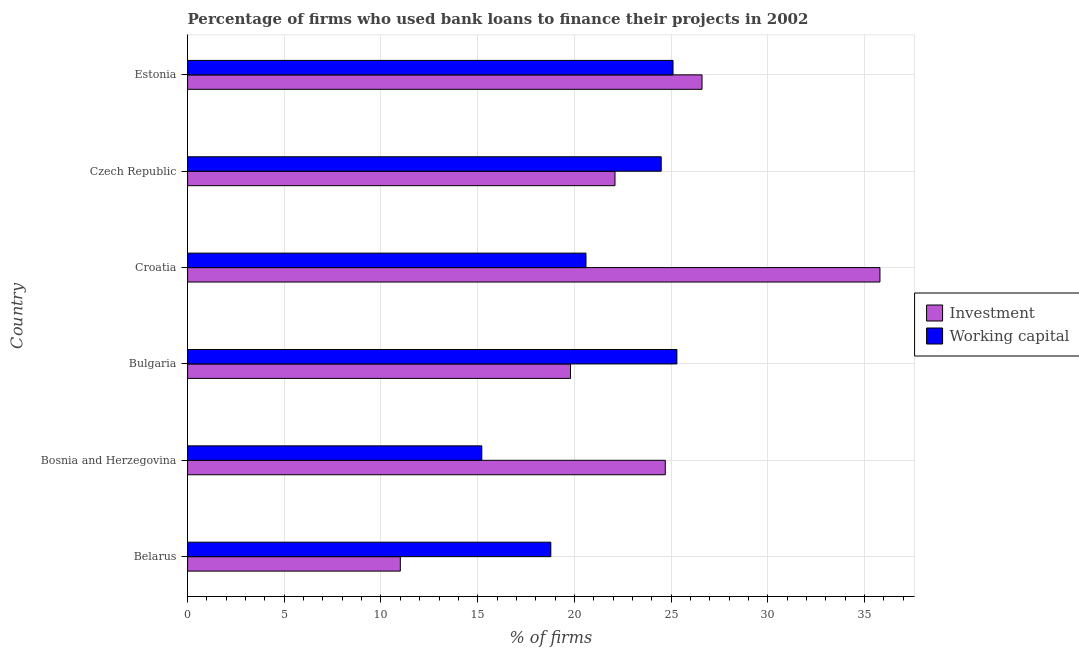Are the number of bars per tick equal to the number of legend labels?
Keep it short and to the point. Yes. Are the number of bars on each tick of the Y-axis equal?
Keep it short and to the point. Yes. What is the label of the 5th group of bars from the top?
Keep it short and to the point. Bosnia and Herzegovina. What is the percentage of firms using banks to finance working capital in Bosnia and Herzegovina?
Your answer should be very brief. 15.21. Across all countries, what is the maximum percentage of firms using banks to finance investment?
Offer a terse response. 35.8. Across all countries, what is the minimum percentage of firms using banks to finance investment?
Keep it short and to the point. 11. In which country was the percentage of firms using banks to finance working capital maximum?
Give a very brief answer. Bulgaria. In which country was the percentage of firms using banks to finance investment minimum?
Provide a short and direct response. Belarus. What is the total percentage of firms using banks to finance working capital in the graph?
Offer a terse response. 129.48. What is the difference between the percentage of firms using banks to finance working capital in Estonia and the percentage of firms using banks to finance investment in Croatia?
Provide a short and direct response. -10.7. What is the average percentage of firms using banks to finance working capital per country?
Provide a succinct answer. 21.58. What is the difference between the percentage of firms using banks to finance working capital and percentage of firms using banks to finance investment in Croatia?
Make the answer very short. -15.2. What is the ratio of the percentage of firms using banks to finance working capital in Bulgaria to that in Croatia?
Give a very brief answer. 1.23. Is the percentage of firms using banks to finance working capital in Croatia less than that in Estonia?
Your answer should be very brief. Yes. What is the difference between the highest and the lowest percentage of firms using banks to finance investment?
Ensure brevity in your answer.  24.8. In how many countries, is the percentage of firms using banks to finance working capital greater than the average percentage of firms using banks to finance working capital taken over all countries?
Ensure brevity in your answer.  3. Is the sum of the percentage of firms using banks to finance working capital in Bosnia and Herzegovina and Estonia greater than the maximum percentage of firms using banks to finance investment across all countries?
Provide a short and direct response. Yes. What does the 2nd bar from the top in Croatia represents?
Offer a terse response. Investment. What does the 1st bar from the bottom in Bulgaria represents?
Your answer should be compact. Investment. Are all the bars in the graph horizontal?
Your answer should be very brief. Yes. How many countries are there in the graph?
Offer a very short reply. 6. What is the difference between two consecutive major ticks on the X-axis?
Your response must be concise. 5. Are the values on the major ticks of X-axis written in scientific E-notation?
Offer a terse response. No. Where does the legend appear in the graph?
Offer a terse response. Center right. How many legend labels are there?
Offer a terse response. 2. How are the legend labels stacked?
Provide a short and direct response. Vertical. What is the title of the graph?
Keep it short and to the point. Percentage of firms who used bank loans to finance their projects in 2002. What is the label or title of the X-axis?
Ensure brevity in your answer.  % of firms. What is the % of firms of Working capital in Belarus?
Provide a short and direct response. 18.78. What is the % of firms of Investment in Bosnia and Herzegovina?
Offer a very short reply. 24.7. What is the % of firms of Working capital in Bosnia and Herzegovina?
Give a very brief answer. 15.21. What is the % of firms of Investment in Bulgaria?
Provide a succinct answer. 19.8. What is the % of firms in Working capital in Bulgaria?
Make the answer very short. 25.3. What is the % of firms in Investment in Croatia?
Provide a succinct answer. 35.8. What is the % of firms in Working capital in Croatia?
Keep it short and to the point. 20.6. What is the % of firms of Investment in Czech Republic?
Offer a very short reply. 22.1. What is the % of firms in Working capital in Czech Republic?
Your answer should be compact. 24.49. What is the % of firms of Investment in Estonia?
Give a very brief answer. 26.6. What is the % of firms in Working capital in Estonia?
Keep it short and to the point. 25.1. Across all countries, what is the maximum % of firms of Investment?
Make the answer very short. 35.8. Across all countries, what is the maximum % of firms of Working capital?
Provide a short and direct response. 25.3. Across all countries, what is the minimum % of firms in Working capital?
Offer a terse response. 15.21. What is the total % of firms of Investment in the graph?
Offer a terse response. 140. What is the total % of firms of Working capital in the graph?
Your answer should be very brief. 129.48. What is the difference between the % of firms of Investment in Belarus and that in Bosnia and Herzegovina?
Ensure brevity in your answer.  -13.7. What is the difference between the % of firms of Working capital in Belarus and that in Bosnia and Herzegovina?
Keep it short and to the point. 3.57. What is the difference between the % of firms of Working capital in Belarus and that in Bulgaria?
Your response must be concise. -6.52. What is the difference between the % of firms of Investment in Belarus and that in Croatia?
Make the answer very short. -24.8. What is the difference between the % of firms of Working capital in Belarus and that in Croatia?
Your answer should be compact. -1.82. What is the difference between the % of firms in Investment in Belarus and that in Czech Republic?
Your answer should be very brief. -11.1. What is the difference between the % of firms in Working capital in Belarus and that in Czech Republic?
Your answer should be very brief. -5.71. What is the difference between the % of firms of Investment in Belarus and that in Estonia?
Your answer should be compact. -15.6. What is the difference between the % of firms in Working capital in Belarus and that in Estonia?
Your answer should be very brief. -6.32. What is the difference between the % of firms in Investment in Bosnia and Herzegovina and that in Bulgaria?
Provide a short and direct response. 4.9. What is the difference between the % of firms of Working capital in Bosnia and Herzegovina and that in Bulgaria?
Your response must be concise. -10.09. What is the difference between the % of firms of Investment in Bosnia and Herzegovina and that in Croatia?
Keep it short and to the point. -11.1. What is the difference between the % of firms of Working capital in Bosnia and Herzegovina and that in Croatia?
Ensure brevity in your answer.  -5.39. What is the difference between the % of firms of Investment in Bosnia and Herzegovina and that in Czech Republic?
Your response must be concise. 2.6. What is the difference between the % of firms in Working capital in Bosnia and Herzegovina and that in Czech Republic?
Make the answer very short. -9.28. What is the difference between the % of firms in Investment in Bosnia and Herzegovina and that in Estonia?
Offer a terse response. -1.9. What is the difference between the % of firms in Working capital in Bosnia and Herzegovina and that in Estonia?
Offer a terse response. -9.89. What is the difference between the % of firms of Working capital in Bulgaria and that in Czech Republic?
Ensure brevity in your answer.  0.81. What is the difference between the % of firms of Working capital in Bulgaria and that in Estonia?
Keep it short and to the point. 0.2. What is the difference between the % of firms of Investment in Croatia and that in Czech Republic?
Offer a very short reply. 13.7. What is the difference between the % of firms in Working capital in Croatia and that in Czech Republic?
Provide a succinct answer. -3.89. What is the difference between the % of firms in Investment in Croatia and that in Estonia?
Give a very brief answer. 9.2. What is the difference between the % of firms in Working capital in Czech Republic and that in Estonia?
Your response must be concise. -0.61. What is the difference between the % of firms of Investment in Belarus and the % of firms of Working capital in Bosnia and Herzegovina?
Provide a short and direct response. -4.21. What is the difference between the % of firms of Investment in Belarus and the % of firms of Working capital in Bulgaria?
Offer a terse response. -14.3. What is the difference between the % of firms of Investment in Belarus and the % of firms of Working capital in Croatia?
Provide a short and direct response. -9.6. What is the difference between the % of firms of Investment in Belarus and the % of firms of Working capital in Czech Republic?
Keep it short and to the point. -13.49. What is the difference between the % of firms in Investment in Belarus and the % of firms in Working capital in Estonia?
Your answer should be compact. -14.1. What is the difference between the % of firms of Investment in Bosnia and Herzegovina and the % of firms of Working capital in Croatia?
Offer a very short reply. 4.1. What is the difference between the % of firms of Investment in Bosnia and Herzegovina and the % of firms of Working capital in Czech Republic?
Provide a succinct answer. 0.21. What is the difference between the % of firms in Investment in Bulgaria and the % of firms in Working capital in Czech Republic?
Ensure brevity in your answer.  -4.69. What is the difference between the % of firms in Investment in Croatia and the % of firms in Working capital in Czech Republic?
Offer a very short reply. 11.31. What is the difference between the % of firms in Investment in Croatia and the % of firms in Working capital in Estonia?
Provide a succinct answer. 10.7. What is the average % of firms in Investment per country?
Your answer should be very brief. 23.33. What is the average % of firms of Working capital per country?
Provide a succinct answer. 21.58. What is the difference between the % of firms in Investment and % of firms in Working capital in Belarus?
Provide a short and direct response. -7.78. What is the difference between the % of firms in Investment and % of firms in Working capital in Bosnia and Herzegovina?
Your response must be concise. 9.49. What is the difference between the % of firms in Investment and % of firms in Working capital in Croatia?
Make the answer very short. 15.2. What is the difference between the % of firms in Investment and % of firms in Working capital in Czech Republic?
Give a very brief answer. -2.39. What is the difference between the % of firms in Investment and % of firms in Working capital in Estonia?
Your answer should be very brief. 1.5. What is the ratio of the % of firms in Investment in Belarus to that in Bosnia and Herzegovina?
Your response must be concise. 0.45. What is the ratio of the % of firms in Working capital in Belarus to that in Bosnia and Herzegovina?
Make the answer very short. 1.23. What is the ratio of the % of firms of Investment in Belarus to that in Bulgaria?
Give a very brief answer. 0.56. What is the ratio of the % of firms in Working capital in Belarus to that in Bulgaria?
Make the answer very short. 0.74. What is the ratio of the % of firms of Investment in Belarus to that in Croatia?
Offer a terse response. 0.31. What is the ratio of the % of firms in Working capital in Belarus to that in Croatia?
Offer a terse response. 0.91. What is the ratio of the % of firms of Investment in Belarus to that in Czech Republic?
Provide a succinct answer. 0.5. What is the ratio of the % of firms of Working capital in Belarus to that in Czech Republic?
Ensure brevity in your answer.  0.77. What is the ratio of the % of firms of Investment in Belarus to that in Estonia?
Offer a very short reply. 0.41. What is the ratio of the % of firms of Working capital in Belarus to that in Estonia?
Your answer should be very brief. 0.75. What is the ratio of the % of firms in Investment in Bosnia and Herzegovina to that in Bulgaria?
Make the answer very short. 1.25. What is the ratio of the % of firms in Working capital in Bosnia and Herzegovina to that in Bulgaria?
Your response must be concise. 0.6. What is the ratio of the % of firms in Investment in Bosnia and Herzegovina to that in Croatia?
Your response must be concise. 0.69. What is the ratio of the % of firms in Working capital in Bosnia and Herzegovina to that in Croatia?
Provide a short and direct response. 0.74. What is the ratio of the % of firms in Investment in Bosnia and Herzegovina to that in Czech Republic?
Provide a succinct answer. 1.12. What is the ratio of the % of firms in Working capital in Bosnia and Herzegovina to that in Czech Republic?
Offer a very short reply. 0.62. What is the ratio of the % of firms of Working capital in Bosnia and Herzegovina to that in Estonia?
Provide a succinct answer. 0.61. What is the ratio of the % of firms of Investment in Bulgaria to that in Croatia?
Offer a terse response. 0.55. What is the ratio of the % of firms of Working capital in Bulgaria to that in Croatia?
Provide a short and direct response. 1.23. What is the ratio of the % of firms in Investment in Bulgaria to that in Czech Republic?
Your answer should be very brief. 0.9. What is the ratio of the % of firms of Working capital in Bulgaria to that in Czech Republic?
Offer a very short reply. 1.03. What is the ratio of the % of firms in Investment in Bulgaria to that in Estonia?
Give a very brief answer. 0.74. What is the ratio of the % of firms in Working capital in Bulgaria to that in Estonia?
Your answer should be compact. 1.01. What is the ratio of the % of firms in Investment in Croatia to that in Czech Republic?
Your response must be concise. 1.62. What is the ratio of the % of firms of Working capital in Croatia to that in Czech Republic?
Give a very brief answer. 0.84. What is the ratio of the % of firms of Investment in Croatia to that in Estonia?
Provide a succinct answer. 1.35. What is the ratio of the % of firms of Working capital in Croatia to that in Estonia?
Ensure brevity in your answer.  0.82. What is the ratio of the % of firms of Investment in Czech Republic to that in Estonia?
Provide a short and direct response. 0.83. What is the ratio of the % of firms of Working capital in Czech Republic to that in Estonia?
Your answer should be very brief. 0.98. What is the difference between the highest and the second highest % of firms in Investment?
Offer a very short reply. 9.2. What is the difference between the highest and the lowest % of firms of Investment?
Give a very brief answer. 24.8. What is the difference between the highest and the lowest % of firms of Working capital?
Offer a very short reply. 10.09. 